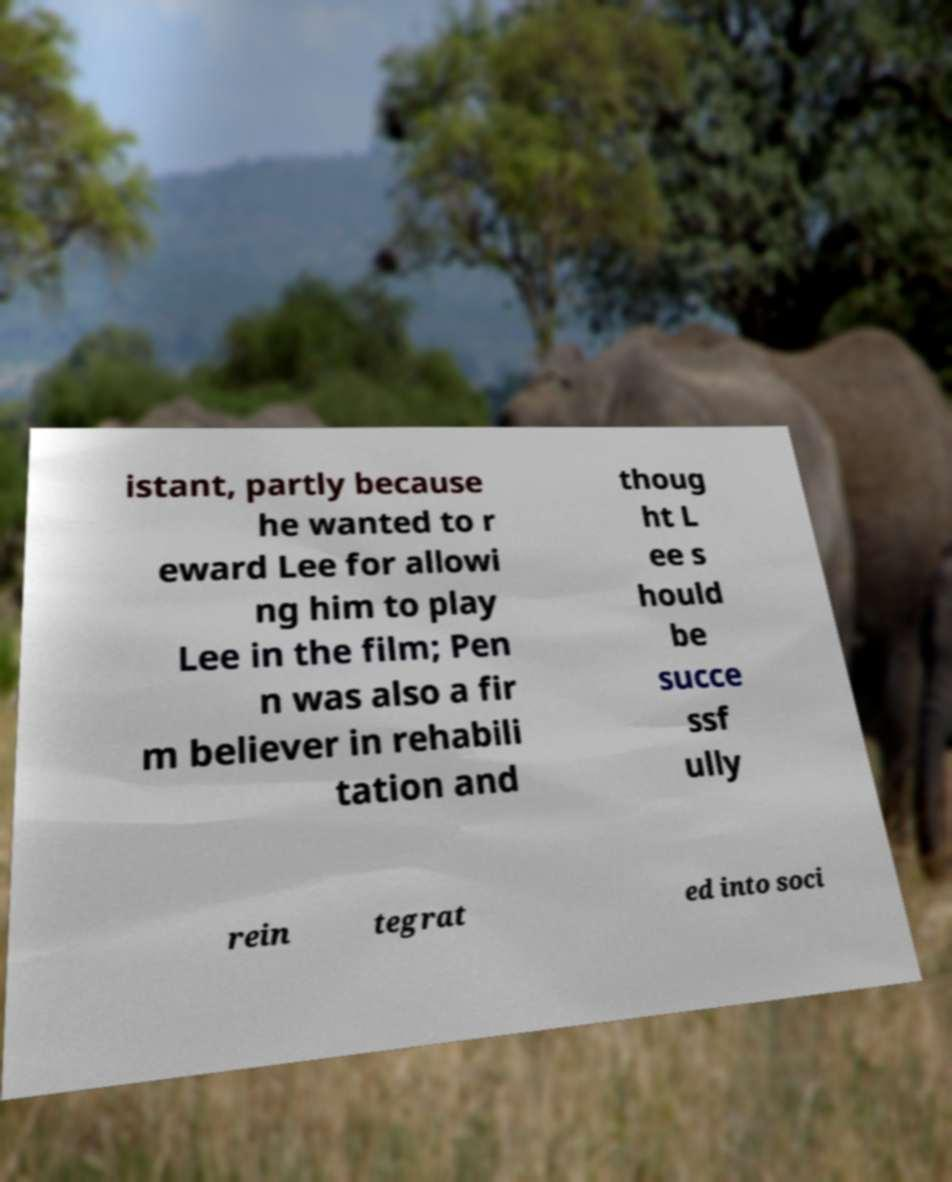I need the written content from this picture converted into text. Can you do that? istant, partly because he wanted to r eward Lee for allowi ng him to play Lee in the film; Pen n was also a fir m believer in rehabili tation and thoug ht L ee s hould be succe ssf ully rein tegrat ed into soci 